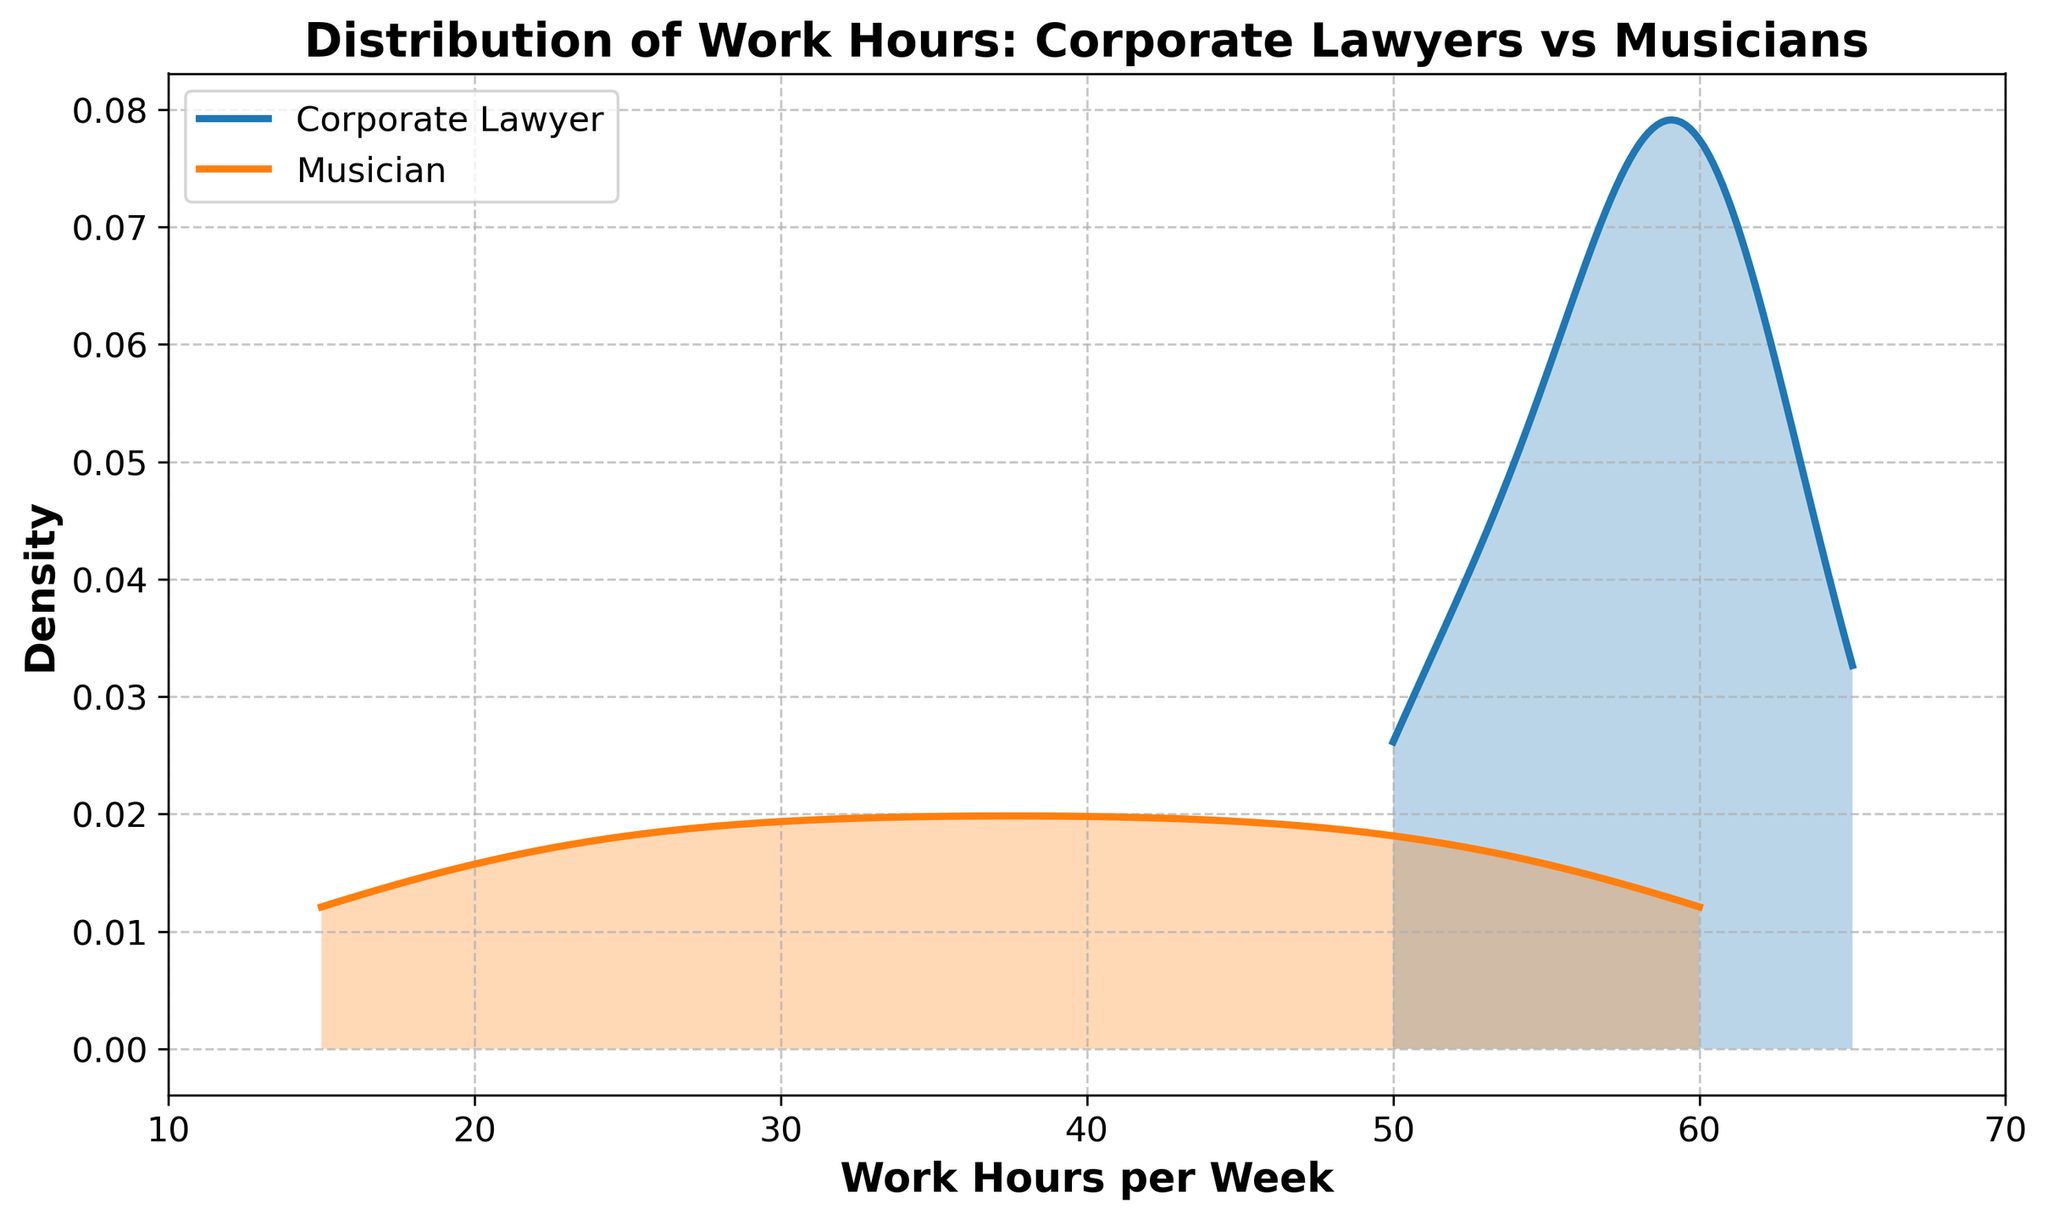What is the title of the figure? The title is displayed at the top of the figure, indicating the focus or subject of the plot. In this case, it summarizes the comparison between the two occupations regarding their work hours distribution.
Answer: Distribution of Work Hours: Corporate Lawyers vs Musicians What variables are represented on the x-axis and y-axis? The x-axis represents the number of work hours per week, while the y-axis represents the density, indicating how frequently certain work hours occur in the data sets for each occupation.
Answer: Work Hours per Week, Density Which occupation typically works more hours per week? By observing the density curves, the Corporate Lawyer curve is shifted to the right, indicating higher work hours on average compared to Musicians.
Answer: Corporate Lawyer What is the range of work hours for musicians? The lower and upper limits of the x-axis for the Musicians' distribution show the range of working hours. Refer to the filled curve specific to the Musicians to determine these limits.
Answer: 15 to 60 hours How does the work hours density peak for Corporate Lawyers compare to Musicians? The peak represents the highest density of work hours, meaning the most common range for each occupation. Comparing them shows which hours are most prevalent for both groups.
Answer: Corporate Lawyers' density peak is higher and occurs at a higher number of hours Are there any overlapping work hours between the two occupations? Look at the sections where the two curves overlap on the x-axis to determine common ranges.
Answer: Yes, in the 50 to 60 hours range What can you infer about the variability of work hours for Musicians compared to Corporate Lawyers? The width of the density curve indicates variability. A wider curve suggests more variability, while a narrower curve indicates consistency around certain hours.
Answer: Musicians have more variability Which occupation has a more consistent work schedule? Consistency can be inferred from the narrower distribution of density curves, as it suggests less variability in work hours.
Answer: Corporate Lawyer Is there a significant density of musicians working very few hours (e.g., 20 hours or less)? Examine the density curve for Musicians in the lower range of hours to see if there's a peak suggesting many work few hours.
Answer: Yes, there is a presence What does the area under the density curve represent? The area under each curve represents the probability distribution of work hours for each occupation. It sums up to 1, indicating all possible work hour scenarios for each group.
Answer: Probability distribution 